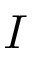<formula> <loc_0><loc_0><loc_500><loc_500>I</formula> 